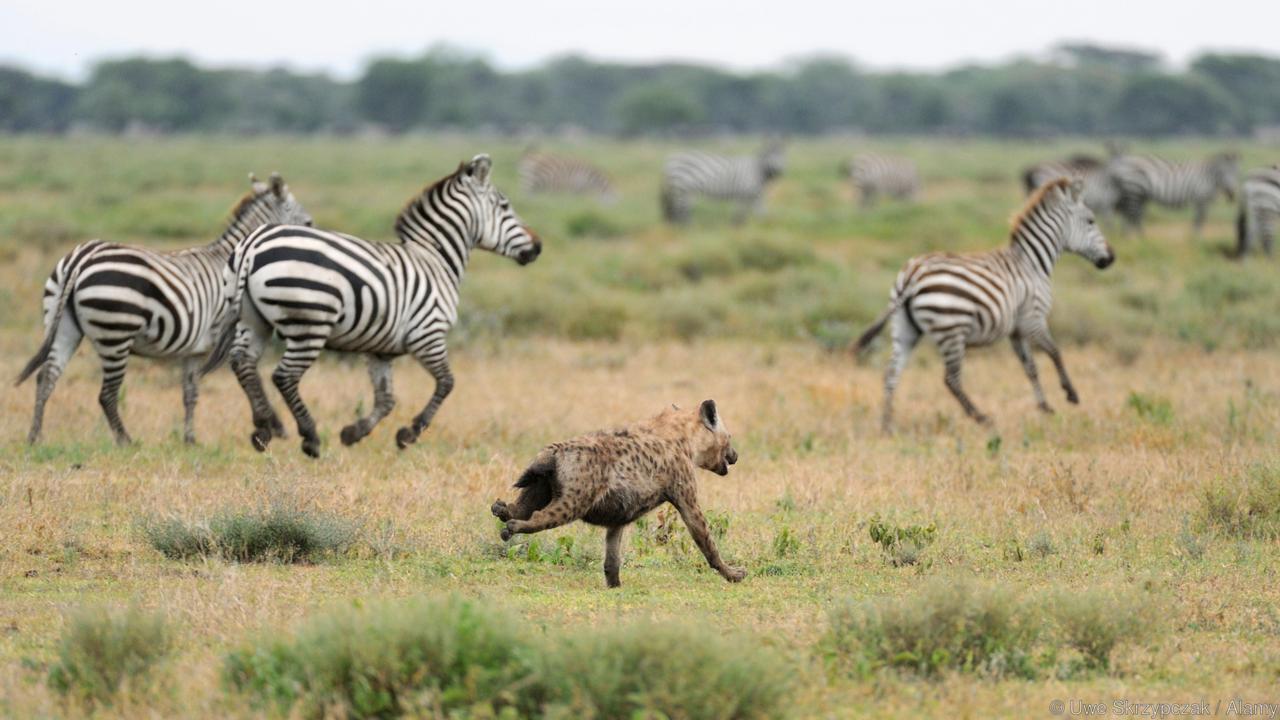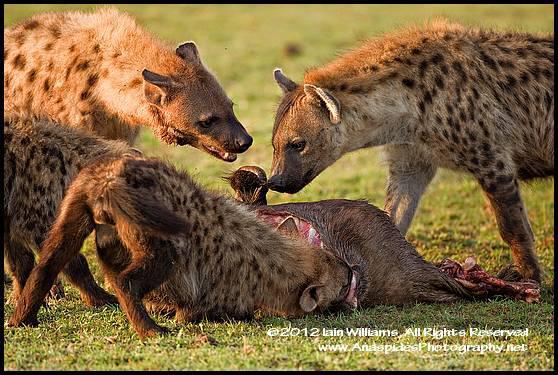The first image is the image on the left, the second image is the image on the right. Examine the images to the left and right. Is the description "One of the images contains birds along side the animals." accurate? Answer yes or no. No. The first image is the image on the left, the second image is the image on the right. Considering the images on both sides, is "Left image includes zebra in an image with hyena." valid? Answer yes or no. Yes. 